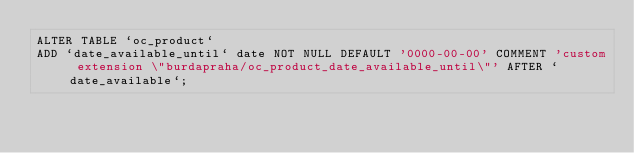Convert code to text. <code><loc_0><loc_0><loc_500><loc_500><_SQL_>ALTER TABLE `oc_product`
ADD `date_available_until` date NOT NULL DEFAULT '0000-00-00' COMMENT 'custom extension \"burdapraha/oc_product_date_available_until\"' AFTER `date_available`;</code> 